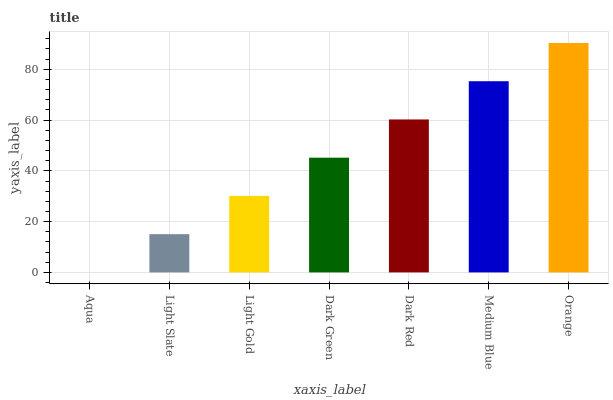Is Aqua the minimum?
Answer yes or no. Yes. Is Orange the maximum?
Answer yes or no. Yes. Is Light Slate the minimum?
Answer yes or no. No. Is Light Slate the maximum?
Answer yes or no. No. Is Light Slate greater than Aqua?
Answer yes or no. Yes. Is Aqua less than Light Slate?
Answer yes or no. Yes. Is Aqua greater than Light Slate?
Answer yes or no. No. Is Light Slate less than Aqua?
Answer yes or no. No. Is Dark Green the high median?
Answer yes or no. Yes. Is Dark Green the low median?
Answer yes or no. Yes. Is Light Slate the high median?
Answer yes or no. No. Is Medium Blue the low median?
Answer yes or no. No. 